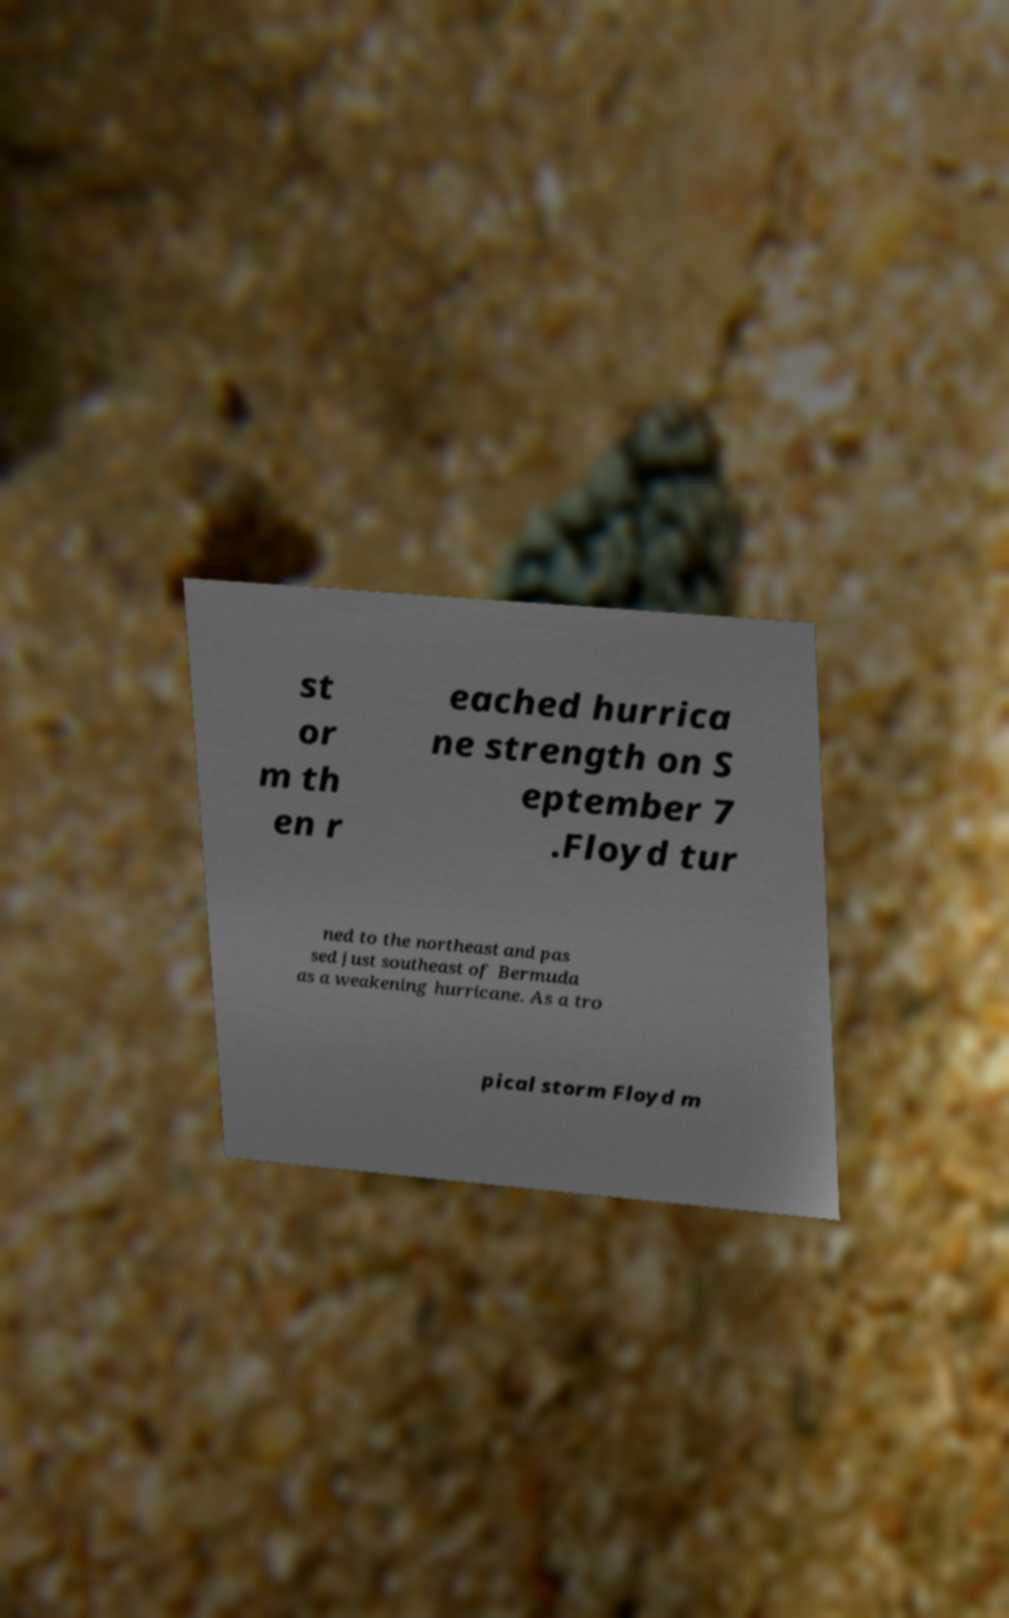Please read and relay the text visible in this image. What does it say? st or m th en r eached hurrica ne strength on S eptember 7 .Floyd tur ned to the northeast and pas sed just southeast of Bermuda as a weakening hurricane. As a tro pical storm Floyd m 